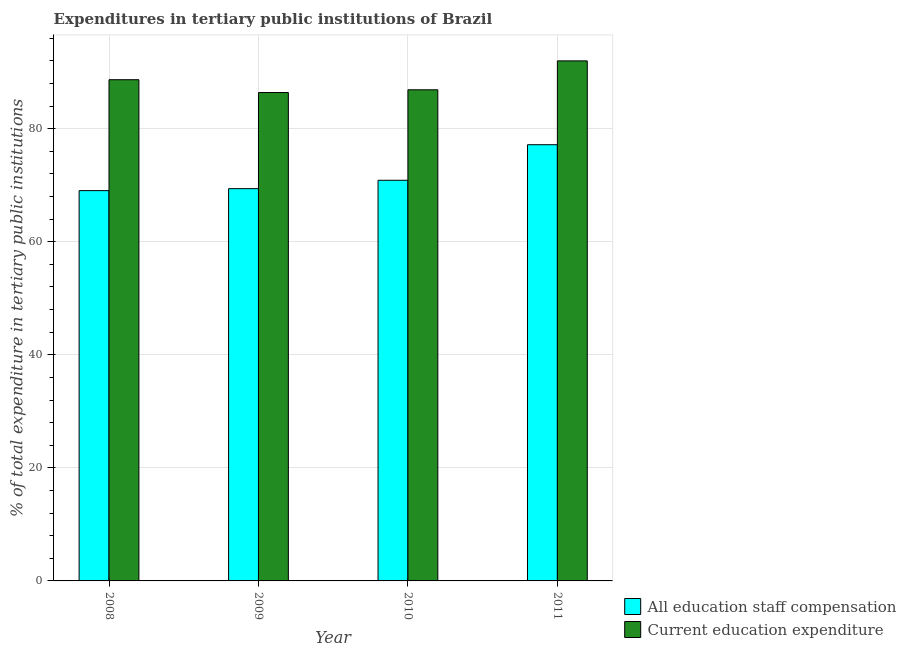How many different coloured bars are there?
Make the answer very short. 2. How many groups of bars are there?
Ensure brevity in your answer.  4. Are the number of bars per tick equal to the number of legend labels?
Keep it short and to the point. Yes. How many bars are there on the 3rd tick from the right?
Offer a terse response. 2. What is the label of the 4th group of bars from the left?
Your answer should be very brief. 2011. What is the expenditure in education in 2011?
Your response must be concise. 91.99. Across all years, what is the maximum expenditure in education?
Offer a terse response. 91.99. Across all years, what is the minimum expenditure in staff compensation?
Offer a terse response. 69.03. What is the total expenditure in staff compensation in the graph?
Ensure brevity in your answer.  286.44. What is the difference between the expenditure in staff compensation in 2008 and that in 2009?
Your answer should be very brief. -0.35. What is the difference between the expenditure in education in 2011 and the expenditure in staff compensation in 2008?
Your answer should be very brief. 3.33. What is the average expenditure in staff compensation per year?
Give a very brief answer. 71.61. What is the ratio of the expenditure in staff compensation in 2008 to that in 2011?
Provide a succinct answer. 0.89. Is the expenditure in staff compensation in 2010 less than that in 2011?
Make the answer very short. Yes. Is the difference between the expenditure in education in 2008 and 2009 greater than the difference between the expenditure in staff compensation in 2008 and 2009?
Provide a succinct answer. No. What is the difference between the highest and the second highest expenditure in staff compensation?
Your answer should be very brief. 6.29. What is the difference between the highest and the lowest expenditure in staff compensation?
Ensure brevity in your answer.  8.12. In how many years, is the expenditure in education greater than the average expenditure in education taken over all years?
Your answer should be very brief. 2. Is the sum of the expenditure in education in 2008 and 2010 greater than the maximum expenditure in staff compensation across all years?
Ensure brevity in your answer.  Yes. What does the 1st bar from the left in 2008 represents?
Your response must be concise. All education staff compensation. What does the 2nd bar from the right in 2008 represents?
Keep it short and to the point. All education staff compensation. How many bars are there?
Make the answer very short. 8. Are all the bars in the graph horizontal?
Offer a terse response. No. Are the values on the major ticks of Y-axis written in scientific E-notation?
Provide a short and direct response. No. Does the graph contain any zero values?
Offer a very short reply. No. What is the title of the graph?
Ensure brevity in your answer.  Expenditures in tertiary public institutions of Brazil. What is the label or title of the X-axis?
Your response must be concise. Year. What is the label or title of the Y-axis?
Offer a terse response. % of total expenditure in tertiary public institutions. What is the % of total expenditure in tertiary public institutions in All education staff compensation in 2008?
Your answer should be compact. 69.03. What is the % of total expenditure in tertiary public institutions of Current education expenditure in 2008?
Your answer should be compact. 88.65. What is the % of total expenditure in tertiary public institutions of All education staff compensation in 2009?
Your response must be concise. 69.39. What is the % of total expenditure in tertiary public institutions of Current education expenditure in 2009?
Offer a terse response. 86.39. What is the % of total expenditure in tertiary public institutions in All education staff compensation in 2010?
Your answer should be very brief. 70.87. What is the % of total expenditure in tertiary public institutions in Current education expenditure in 2010?
Ensure brevity in your answer.  86.87. What is the % of total expenditure in tertiary public institutions in All education staff compensation in 2011?
Your response must be concise. 77.16. What is the % of total expenditure in tertiary public institutions in Current education expenditure in 2011?
Provide a succinct answer. 91.99. Across all years, what is the maximum % of total expenditure in tertiary public institutions in All education staff compensation?
Your answer should be very brief. 77.16. Across all years, what is the maximum % of total expenditure in tertiary public institutions of Current education expenditure?
Provide a succinct answer. 91.99. Across all years, what is the minimum % of total expenditure in tertiary public institutions of All education staff compensation?
Offer a very short reply. 69.03. Across all years, what is the minimum % of total expenditure in tertiary public institutions in Current education expenditure?
Keep it short and to the point. 86.39. What is the total % of total expenditure in tertiary public institutions in All education staff compensation in the graph?
Offer a terse response. 286.44. What is the total % of total expenditure in tertiary public institutions of Current education expenditure in the graph?
Make the answer very short. 353.9. What is the difference between the % of total expenditure in tertiary public institutions in All education staff compensation in 2008 and that in 2009?
Ensure brevity in your answer.  -0.35. What is the difference between the % of total expenditure in tertiary public institutions in Current education expenditure in 2008 and that in 2009?
Provide a succinct answer. 2.27. What is the difference between the % of total expenditure in tertiary public institutions in All education staff compensation in 2008 and that in 2010?
Offer a terse response. -1.83. What is the difference between the % of total expenditure in tertiary public institutions in Current education expenditure in 2008 and that in 2010?
Ensure brevity in your answer.  1.78. What is the difference between the % of total expenditure in tertiary public institutions of All education staff compensation in 2008 and that in 2011?
Keep it short and to the point. -8.12. What is the difference between the % of total expenditure in tertiary public institutions in Current education expenditure in 2008 and that in 2011?
Give a very brief answer. -3.33. What is the difference between the % of total expenditure in tertiary public institutions in All education staff compensation in 2009 and that in 2010?
Keep it short and to the point. -1.48. What is the difference between the % of total expenditure in tertiary public institutions of Current education expenditure in 2009 and that in 2010?
Offer a terse response. -0.48. What is the difference between the % of total expenditure in tertiary public institutions of All education staff compensation in 2009 and that in 2011?
Your answer should be compact. -7.77. What is the difference between the % of total expenditure in tertiary public institutions in Current education expenditure in 2009 and that in 2011?
Provide a short and direct response. -5.6. What is the difference between the % of total expenditure in tertiary public institutions of All education staff compensation in 2010 and that in 2011?
Your answer should be compact. -6.29. What is the difference between the % of total expenditure in tertiary public institutions of Current education expenditure in 2010 and that in 2011?
Your answer should be compact. -5.11. What is the difference between the % of total expenditure in tertiary public institutions in All education staff compensation in 2008 and the % of total expenditure in tertiary public institutions in Current education expenditure in 2009?
Offer a very short reply. -17.35. What is the difference between the % of total expenditure in tertiary public institutions in All education staff compensation in 2008 and the % of total expenditure in tertiary public institutions in Current education expenditure in 2010?
Provide a short and direct response. -17.84. What is the difference between the % of total expenditure in tertiary public institutions in All education staff compensation in 2008 and the % of total expenditure in tertiary public institutions in Current education expenditure in 2011?
Offer a very short reply. -22.95. What is the difference between the % of total expenditure in tertiary public institutions in All education staff compensation in 2009 and the % of total expenditure in tertiary public institutions in Current education expenditure in 2010?
Your answer should be compact. -17.49. What is the difference between the % of total expenditure in tertiary public institutions in All education staff compensation in 2009 and the % of total expenditure in tertiary public institutions in Current education expenditure in 2011?
Ensure brevity in your answer.  -22.6. What is the difference between the % of total expenditure in tertiary public institutions in All education staff compensation in 2010 and the % of total expenditure in tertiary public institutions in Current education expenditure in 2011?
Make the answer very short. -21.12. What is the average % of total expenditure in tertiary public institutions of All education staff compensation per year?
Provide a succinct answer. 71.61. What is the average % of total expenditure in tertiary public institutions of Current education expenditure per year?
Give a very brief answer. 88.47. In the year 2008, what is the difference between the % of total expenditure in tertiary public institutions of All education staff compensation and % of total expenditure in tertiary public institutions of Current education expenditure?
Offer a terse response. -19.62. In the year 2009, what is the difference between the % of total expenditure in tertiary public institutions of All education staff compensation and % of total expenditure in tertiary public institutions of Current education expenditure?
Your answer should be very brief. -17. In the year 2010, what is the difference between the % of total expenditure in tertiary public institutions of All education staff compensation and % of total expenditure in tertiary public institutions of Current education expenditure?
Offer a very short reply. -16. In the year 2011, what is the difference between the % of total expenditure in tertiary public institutions in All education staff compensation and % of total expenditure in tertiary public institutions in Current education expenditure?
Keep it short and to the point. -14.83. What is the ratio of the % of total expenditure in tertiary public institutions of All education staff compensation in 2008 to that in 2009?
Make the answer very short. 0.99. What is the ratio of the % of total expenditure in tertiary public institutions of Current education expenditure in 2008 to that in 2009?
Ensure brevity in your answer.  1.03. What is the ratio of the % of total expenditure in tertiary public institutions in All education staff compensation in 2008 to that in 2010?
Keep it short and to the point. 0.97. What is the ratio of the % of total expenditure in tertiary public institutions in Current education expenditure in 2008 to that in 2010?
Provide a succinct answer. 1.02. What is the ratio of the % of total expenditure in tertiary public institutions of All education staff compensation in 2008 to that in 2011?
Your answer should be very brief. 0.89. What is the ratio of the % of total expenditure in tertiary public institutions in Current education expenditure in 2008 to that in 2011?
Your answer should be compact. 0.96. What is the ratio of the % of total expenditure in tertiary public institutions in All education staff compensation in 2009 to that in 2010?
Give a very brief answer. 0.98. What is the ratio of the % of total expenditure in tertiary public institutions in All education staff compensation in 2009 to that in 2011?
Keep it short and to the point. 0.9. What is the ratio of the % of total expenditure in tertiary public institutions of Current education expenditure in 2009 to that in 2011?
Provide a succinct answer. 0.94. What is the ratio of the % of total expenditure in tertiary public institutions in All education staff compensation in 2010 to that in 2011?
Give a very brief answer. 0.92. What is the ratio of the % of total expenditure in tertiary public institutions in Current education expenditure in 2010 to that in 2011?
Give a very brief answer. 0.94. What is the difference between the highest and the second highest % of total expenditure in tertiary public institutions of All education staff compensation?
Give a very brief answer. 6.29. What is the difference between the highest and the second highest % of total expenditure in tertiary public institutions in Current education expenditure?
Your response must be concise. 3.33. What is the difference between the highest and the lowest % of total expenditure in tertiary public institutions in All education staff compensation?
Ensure brevity in your answer.  8.12. What is the difference between the highest and the lowest % of total expenditure in tertiary public institutions of Current education expenditure?
Give a very brief answer. 5.6. 